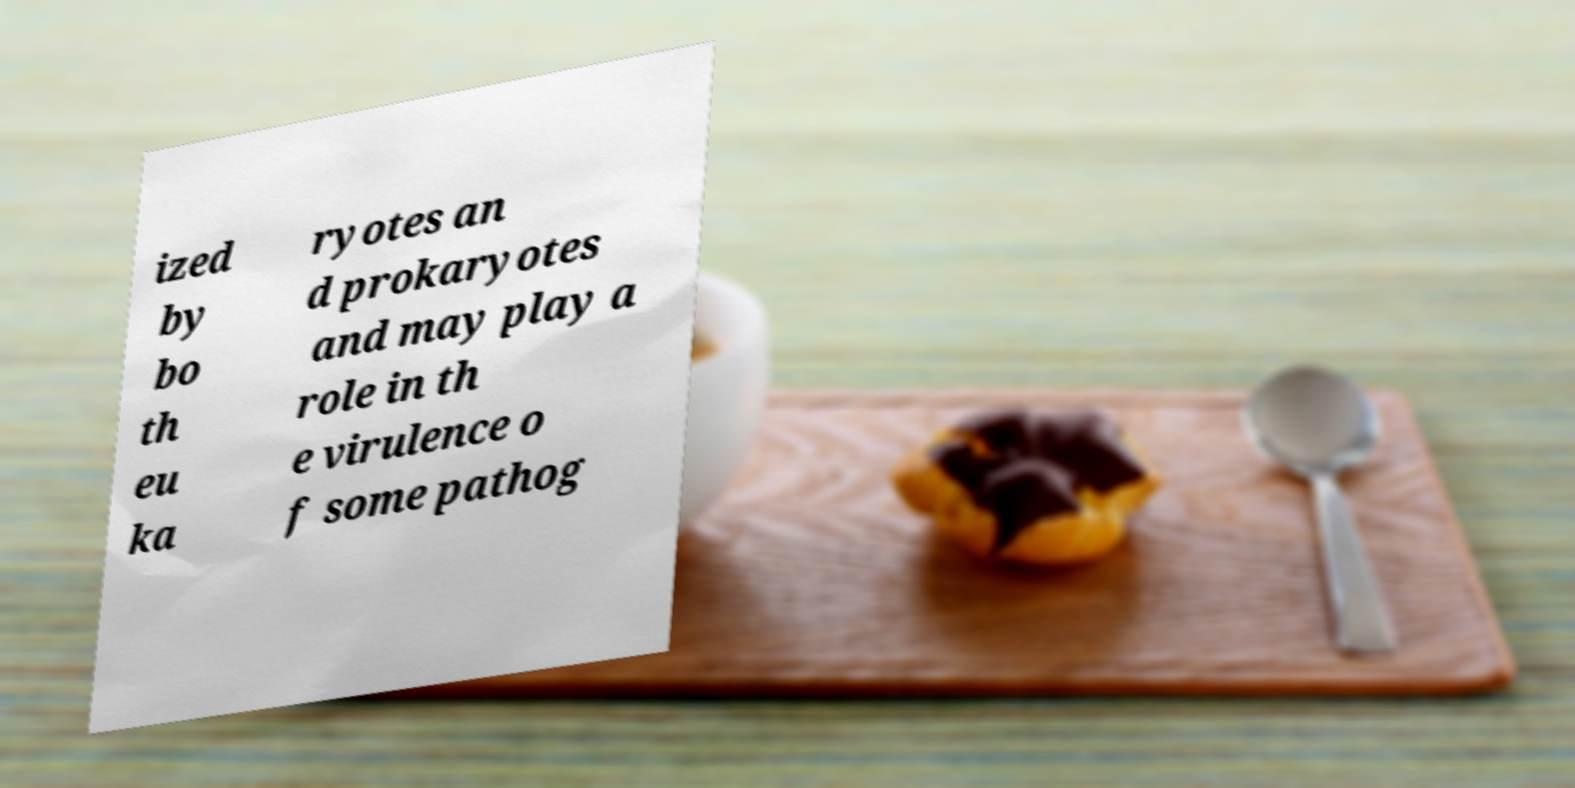Please read and relay the text visible in this image. What does it say? ized by bo th eu ka ryotes an d prokaryotes and may play a role in th e virulence o f some pathog 